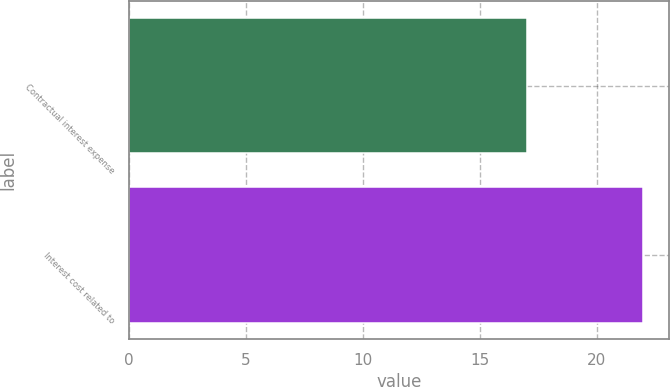<chart> <loc_0><loc_0><loc_500><loc_500><bar_chart><fcel>Contractual interest expense<fcel>Interest cost related to<nl><fcel>17<fcel>22<nl></chart> 